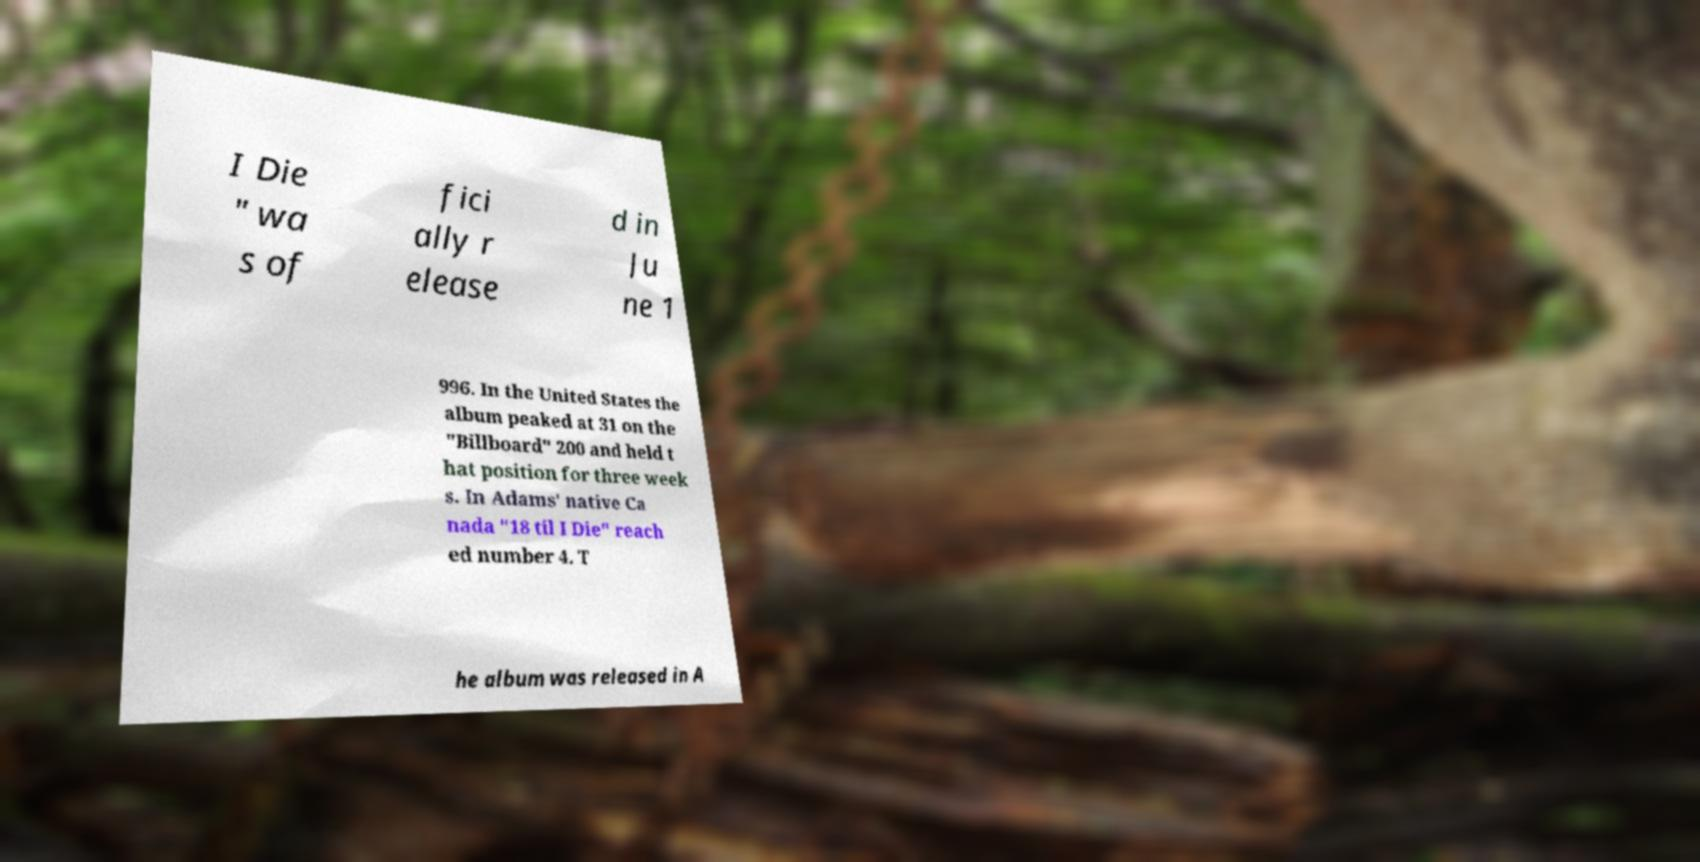What messages or text are displayed in this image? I need them in a readable, typed format. I Die " wa s of fici ally r elease d in Ju ne 1 996. In the United States the album peaked at 31 on the "Billboard" 200 and held t hat position for three week s. In Adams' native Ca nada "18 til I Die" reach ed number 4. T he album was released in A 